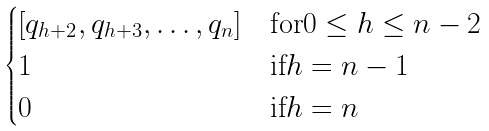<formula> <loc_0><loc_0><loc_500><loc_500>\begin{cases} [ q _ { h + 2 } , q _ { h + 3 } , \dots , q _ { n } ] & \text {for} 0 \leq h \leq n - 2 \\ 1 & \text {if} h = n - 1 \\ 0 & \text {if} h = n \end{cases}</formula> 